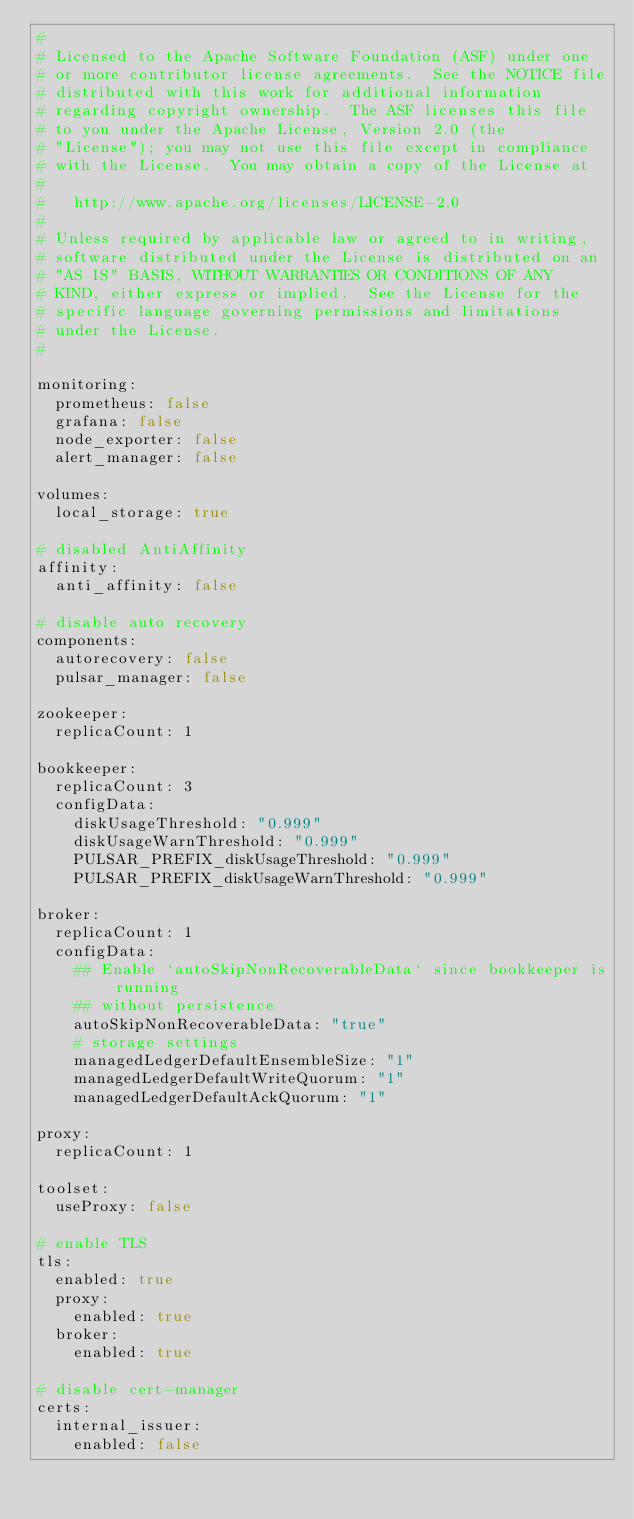Convert code to text. <code><loc_0><loc_0><loc_500><loc_500><_YAML_>#
# Licensed to the Apache Software Foundation (ASF) under one
# or more contributor license agreements.  See the NOTICE file
# distributed with this work for additional information
# regarding copyright ownership.  The ASF licenses this file
# to you under the Apache License, Version 2.0 (the
# "License"); you may not use this file except in compliance
# with the License.  You may obtain a copy of the License at
#
#   http://www.apache.org/licenses/LICENSE-2.0
#
# Unless required by applicable law or agreed to in writing,
# software distributed under the License is distributed on an
# "AS IS" BASIS, WITHOUT WARRANTIES OR CONDITIONS OF ANY
# KIND, either express or implied.  See the License for the
# specific language governing permissions and limitations
# under the License.
#

monitoring:
  prometheus: false
  grafana: false
  node_exporter: false
  alert_manager: false

volumes:
  local_storage: true

# disabled AntiAffinity
affinity:
  anti_affinity: false

# disable auto recovery
components:
  autorecovery: false
  pulsar_manager: false

zookeeper:
  replicaCount: 1

bookkeeper:
  replicaCount: 3
  configData:
    diskUsageThreshold: "0.999"
    diskUsageWarnThreshold: "0.999"
    PULSAR_PREFIX_diskUsageThreshold: "0.999"
    PULSAR_PREFIX_diskUsageWarnThreshold: "0.999"

broker:
  replicaCount: 1
  configData:
    ## Enable `autoSkipNonRecoverableData` since bookkeeper is running
    ## without persistence
    autoSkipNonRecoverableData: "true"
    # storage settings
    managedLedgerDefaultEnsembleSize: "1"
    managedLedgerDefaultWriteQuorum: "1"
    managedLedgerDefaultAckQuorum: "1"

proxy:
  replicaCount: 1

toolset:
  useProxy: false

# enable TLS
tls:
  enabled: true
  proxy:
    enabled: true
  broker:
    enabled: true

# disable cert-manager
certs:
  internal_issuer:
    enabled: false
</code> 